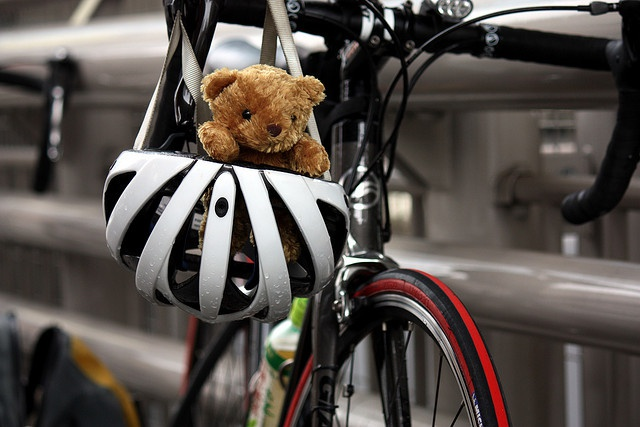Describe the objects in this image and their specific colors. I can see bicycle in black, gray, darkgray, and maroon tones and teddy bear in black, brown, and maroon tones in this image. 